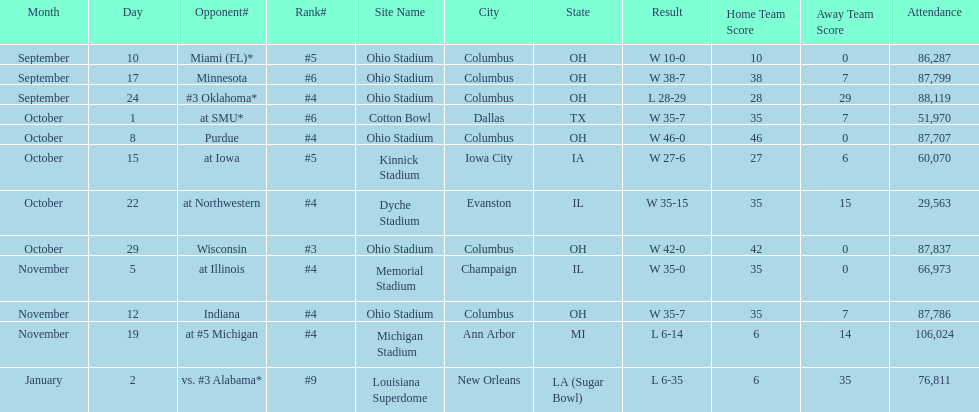In how many games were than more than 80,000 people attending 7. 